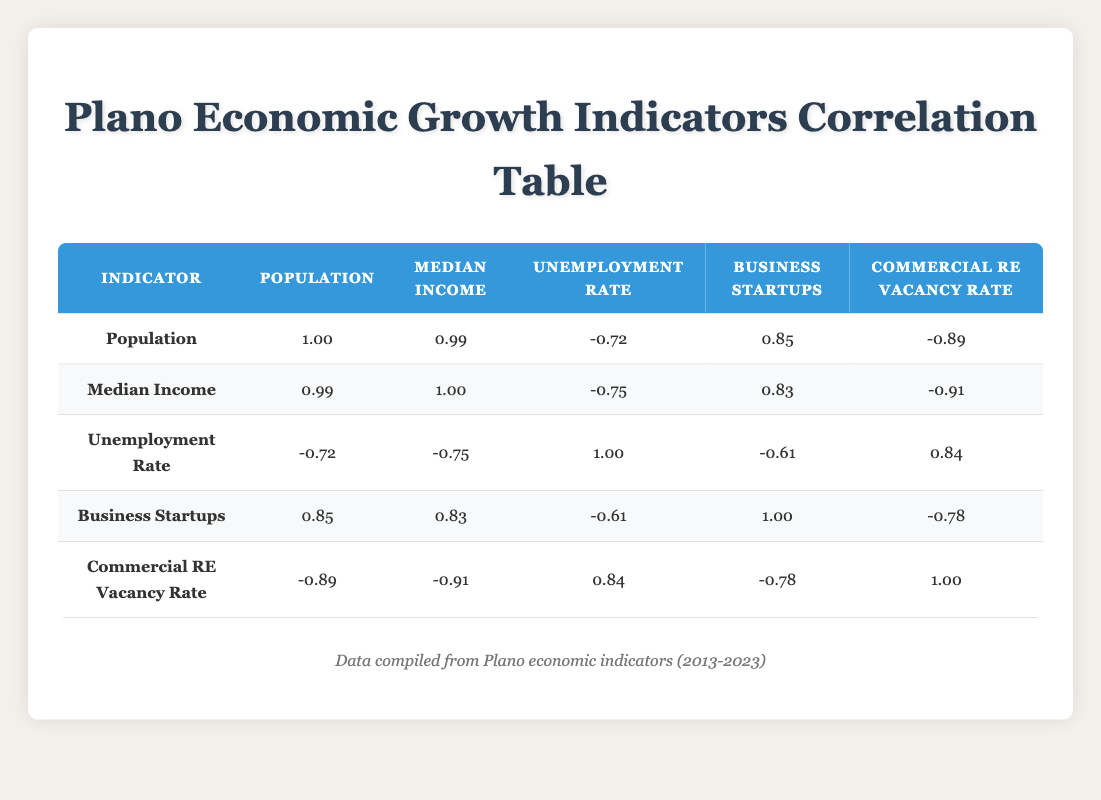What was the population of Plano in 2018? The table shows that the population of Plano in 2018 was listed under the "Population" column for that year, which is 282,000.
Answer: 282000 What was the median income in 2021? In the table, the median income for the year 2021 is provided in the "Median Income" column, which states it is 94,000.
Answer: 94000 Did the unemployment rate decrease from 2013 to 2023? The unemployment rate for 2013 is 6.2 and for 2023 is 4.2. Comparing these two values shows a decrease, confirming that the unemployment rate did decrease over this period.
Answer: Yes What was the average median income for the years 2019 to 2023? To calculate the average median income for these years, add the median incomes: 92,000 (2019) + 93,000 (2020) + 94,000 (2021) + 95,000 (2022) + 96,000 (2023) =  470,000. Then divide by 5 (the number of years): 470,000 / 5 = 94,000.
Answer: 94000 Is there a negative correlation between business startups and the commercial real estate vacancy rate? From the table, the correlation coefficient between business startups and commercial real estate vacancy rate is -0.78, indicating a negative correlation, meaning as one increases, the other decreases.
Answer: Yes Which year had the highest number of business startups, and how many were there? Observing the "Business Startups" column across all years, the highest value is 450, which corresponds to the year 2023.
Answer: 450 in 2023 What is the difference in population between 2013 and 2019? The population in 2013 was 263,500 and in 2019 it was 287,000. The difference can be calculated by subtracting the earlier year from the later year: 287,000 - 263,500 = 23,500.
Answer: 23500 In what year did the unemployment rate first drop below 5 percent? The unemployment rates for each year are checked, and it shows that in 2017, the rate dropped to 4.5, which is the first instance below 5 percent.
Answer: 2017 What was the population of Plano in the year with the highest median income? Reviewing the table, the highest median income is 96,000 in 2023. The corresponding population for that year is 305,000.
Answer: 305000 